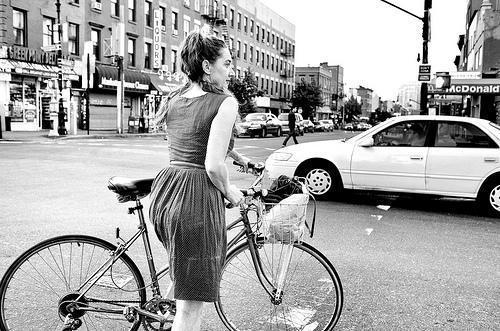How many bicycles are there?
Give a very brief answer. 1. 